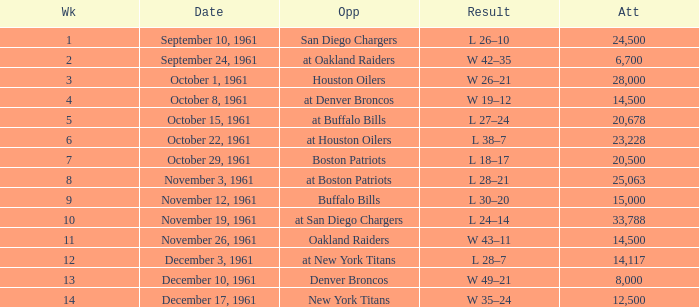What is the low week from october 15, 1961? 5.0. Help me parse the entirety of this table. {'header': ['Wk', 'Date', 'Opp', 'Result', 'Att'], 'rows': [['1', 'September 10, 1961', 'San Diego Chargers', 'L 26–10', '24,500'], ['2', 'September 24, 1961', 'at Oakland Raiders', 'W 42–35', '6,700'], ['3', 'October 1, 1961', 'Houston Oilers', 'W 26–21', '28,000'], ['4', 'October 8, 1961', 'at Denver Broncos', 'W 19–12', '14,500'], ['5', 'October 15, 1961', 'at Buffalo Bills', 'L 27–24', '20,678'], ['6', 'October 22, 1961', 'at Houston Oilers', 'L 38–7', '23,228'], ['7', 'October 29, 1961', 'Boston Patriots', 'L 18–17', '20,500'], ['8', 'November 3, 1961', 'at Boston Patriots', 'L 28–21', '25,063'], ['9', 'November 12, 1961', 'Buffalo Bills', 'L 30–20', '15,000'], ['10', 'November 19, 1961', 'at San Diego Chargers', 'L 24–14', '33,788'], ['11', 'November 26, 1961', 'Oakland Raiders', 'W 43–11', '14,500'], ['12', 'December 3, 1961', 'at New York Titans', 'L 28–7', '14,117'], ['13', 'December 10, 1961', 'Denver Broncos', 'W 49–21', '8,000'], ['14', 'December 17, 1961', 'New York Titans', 'W 35–24', '12,500']]} 